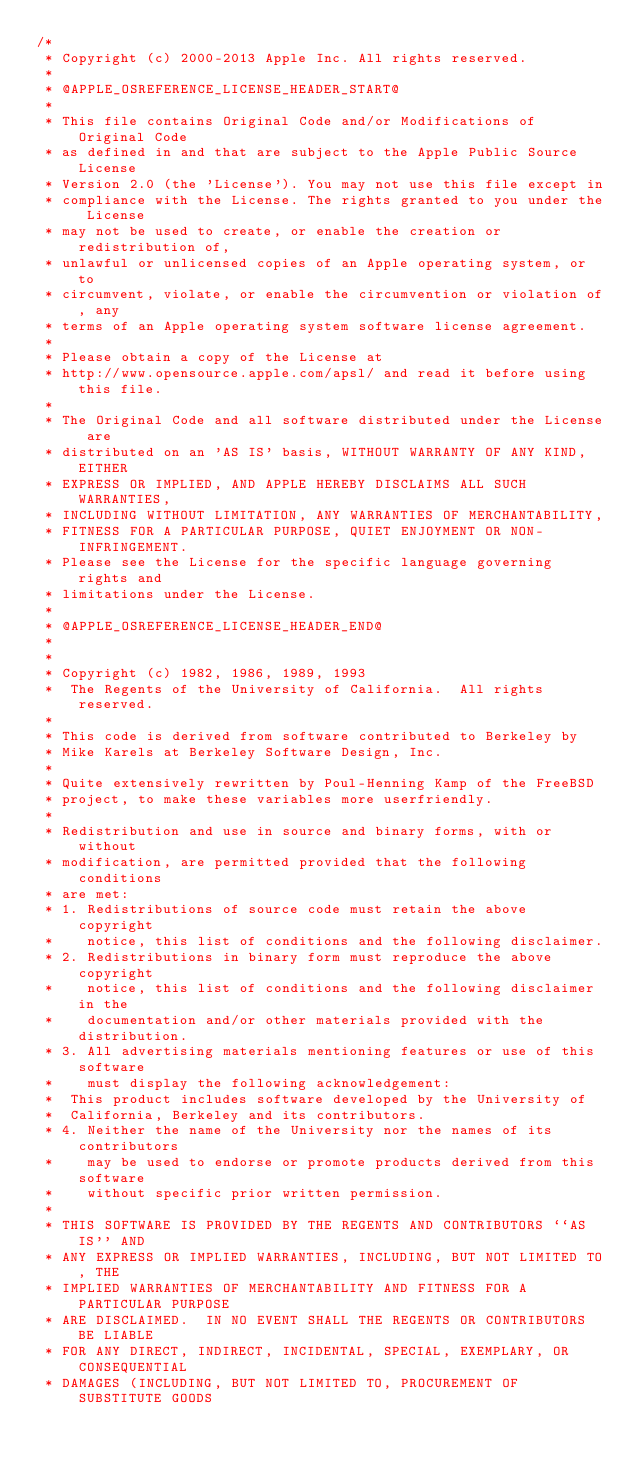Convert code to text. <code><loc_0><loc_0><loc_500><loc_500><_C_>/*
 * Copyright (c) 2000-2013 Apple Inc. All rights reserved.
 *
 * @APPLE_OSREFERENCE_LICENSE_HEADER_START@
 * 
 * This file contains Original Code and/or Modifications of Original Code
 * as defined in and that are subject to the Apple Public Source License
 * Version 2.0 (the 'License'). You may not use this file except in
 * compliance with the License. The rights granted to you under the License
 * may not be used to create, or enable the creation or redistribution of,
 * unlawful or unlicensed copies of an Apple operating system, or to
 * circumvent, violate, or enable the circumvention or violation of, any
 * terms of an Apple operating system software license agreement.
 * 
 * Please obtain a copy of the License at
 * http://www.opensource.apple.com/apsl/ and read it before using this file.
 * 
 * The Original Code and all software distributed under the License are
 * distributed on an 'AS IS' basis, WITHOUT WARRANTY OF ANY KIND, EITHER
 * EXPRESS OR IMPLIED, AND APPLE HEREBY DISCLAIMS ALL SUCH WARRANTIES,
 * INCLUDING WITHOUT LIMITATION, ANY WARRANTIES OF MERCHANTABILITY,
 * FITNESS FOR A PARTICULAR PURPOSE, QUIET ENJOYMENT OR NON-INFRINGEMENT.
 * Please see the License for the specific language governing rights and
 * limitations under the License.
 * 
 * @APPLE_OSREFERENCE_LICENSE_HEADER_END@
 *
 *
 * Copyright (c) 1982, 1986, 1989, 1993
 *	The Regents of the University of California.  All rights reserved.
 *
 * This code is derived from software contributed to Berkeley by
 * Mike Karels at Berkeley Software Design, Inc.
 *
 * Quite extensively rewritten by Poul-Henning Kamp of the FreeBSD
 * project, to make these variables more userfriendly.
 *
 * Redistribution and use in source and binary forms, with or without
 * modification, are permitted provided that the following conditions
 * are met:
 * 1. Redistributions of source code must retain the above copyright
 *    notice, this list of conditions and the following disclaimer.
 * 2. Redistributions in binary form must reproduce the above copyright
 *    notice, this list of conditions and the following disclaimer in the
 *    documentation and/or other materials provided with the distribution.
 * 3. All advertising materials mentioning features or use of this software
 *    must display the following acknowledgement:
 *	This product includes software developed by the University of
 *	California, Berkeley and its contributors.
 * 4. Neither the name of the University nor the names of its contributors
 *    may be used to endorse or promote products derived from this software
 *    without specific prior written permission.
 *
 * THIS SOFTWARE IS PROVIDED BY THE REGENTS AND CONTRIBUTORS ``AS IS'' AND
 * ANY EXPRESS OR IMPLIED WARRANTIES, INCLUDING, BUT NOT LIMITED TO, THE
 * IMPLIED WARRANTIES OF MERCHANTABILITY AND FITNESS FOR A PARTICULAR PURPOSE
 * ARE DISCLAIMED.  IN NO EVENT SHALL THE REGENTS OR CONTRIBUTORS BE LIABLE
 * FOR ANY DIRECT, INDIRECT, INCIDENTAL, SPECIAL, EXEMPLARY, OR CONSEQUENTIAL
 * DAMAGES (INCLUDING, BUT NOT LIMITED TO, PROCUREMENT OF SUBSTITUTE GOODS</code> 